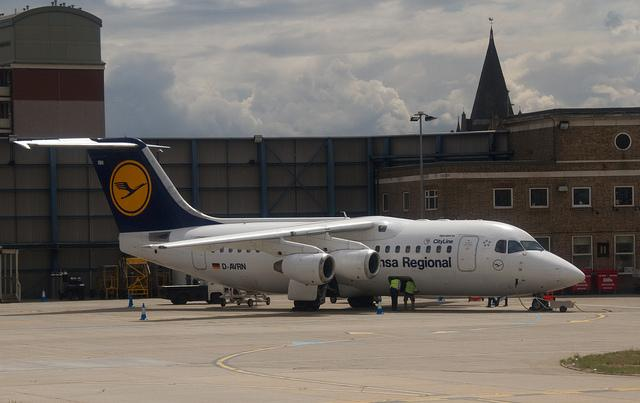What company owns this vehicle?

Choices:
A) ford
B) lufthansa
C) gmc
D) ibm lufthansa 